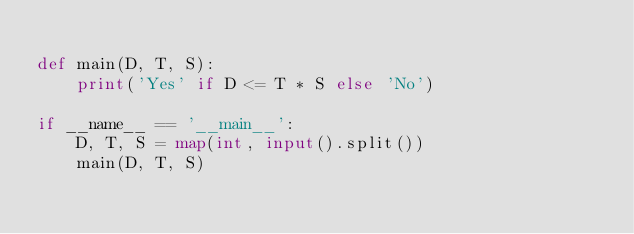Convert code to text. <code><loc_0><loc_0><loc_500><loc_500><_Python_>
def main(D, T, S):
    print('Yes' if D <= T * S else 'No')

if __name__ == '__main__':
    D, T, S = map(int, input().split())
    main(D, T, S)
</code> 